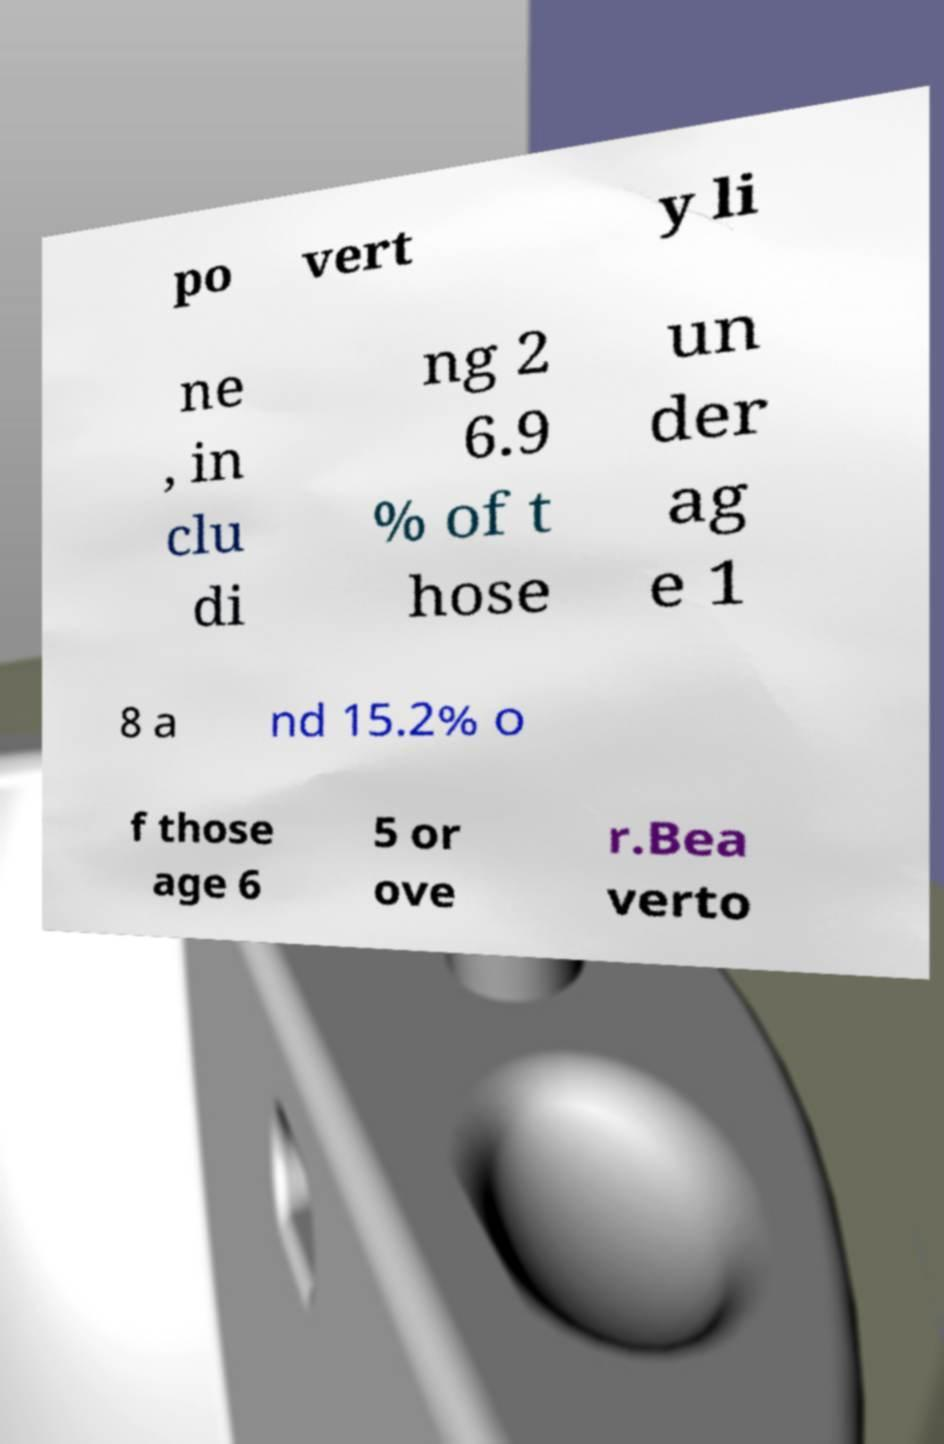For documentation purposes, I need the text within this image transcribed. Could you provide that? po vert y li ne , in clu di ng 2 6.9 % of t hose un der ag e 1 8 a nd 15.2% o f those age 6 5 or ove r.Bea verto 